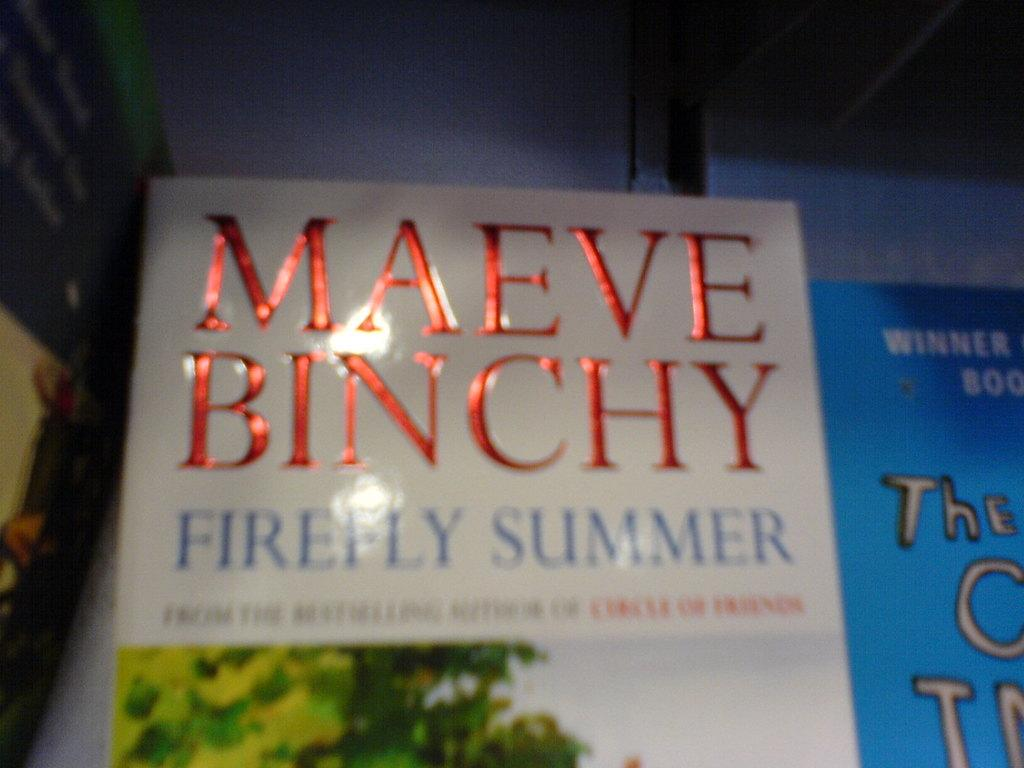Provide a one-sentence caption for the provided image. A book titled Firefly Summer shows the authors name in red foiled lettering. 